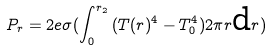Convert formula to latex. <formula><loc_0><loc_0><loc_500><loc_500>P _ { r } = 2 e \sigma ( \int _ { 0 } ^ { r _ { 2 } } { ( T ( r ) ^ { 4 } - T _ { 0 } ^ { 4 } ) 2 \pi r { \text  dr})}</formula> 